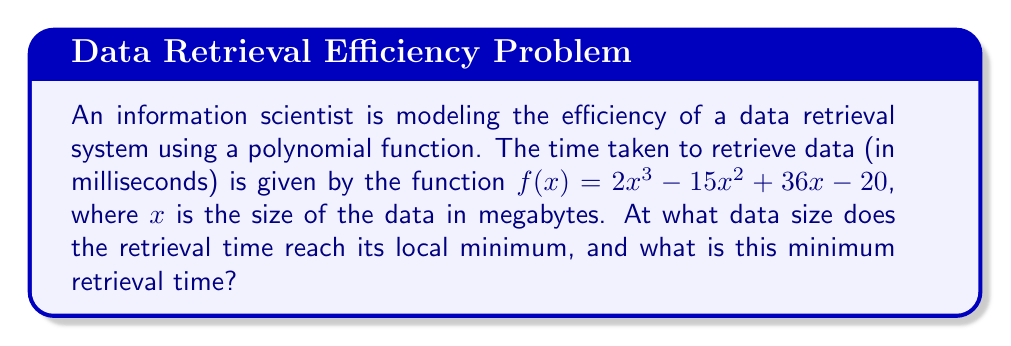Solve this math problem. To find the local minimum of the function, we need to follow these steps:

1) First, we find the derivative of the function:
   $f'(x) = 6x^2 - 30x + 36$

2) To find the critical points, we set $f'(x) = 0$:
   $6x^2 - 30x + 36 = 0$

3) This is a quadratic equation. We can solve it using the quadratic formula:
   $x = \frac{-b \pm \sqrt{b^2 - 4ac}}{2a}$

   Where $a = 6$, $b = -30$, and $c = 36$

4) Plugging in these values:
   $x = \frac{30 \pm \sqrt{(-30)^2 - 4(6)(36)}}{2(6)}$
   $= \frac{30 \pm \sqrt{900 - 864}}{12}$
   $= \frac{30 \pm \sqrt{36}}{12}$
   $= \frac{30 \pm 6}{12}$

5) This gives us two solutions:
   $x_1 = \frac{30 + 6}{12} = 3$
   $x_2 = \frac{30 - 6}{12} = 2$

6) To determine which of these is the local minimum, we can check the second derivative:
   $f''(x) = 12x - 30$

   At $x = 3$: $f''(3) = 12(3) - 30 = 6 > 0$
   At $x = 2$: $f''(2) = 12(2) - 30 = -6 < 0$

   Since $f''(3) > 0$, $x = 3$ is the local minimum.

7) To find the minimum retrieval time, we plug $x = 3$ into the original function:
   $f(3) = 2(3)^3 - 15(3)^2 + 36(3) - 20$
   $= 54 - 135 + 108 - 20$
   $= 7$

Therefore, the retrieval time reaches its local minimum when the data size is 3 MB, and the minimum retrieval time is 7 ms.
Answer: Data size: 3 MB; Minimum retrieval time: 7 ms 